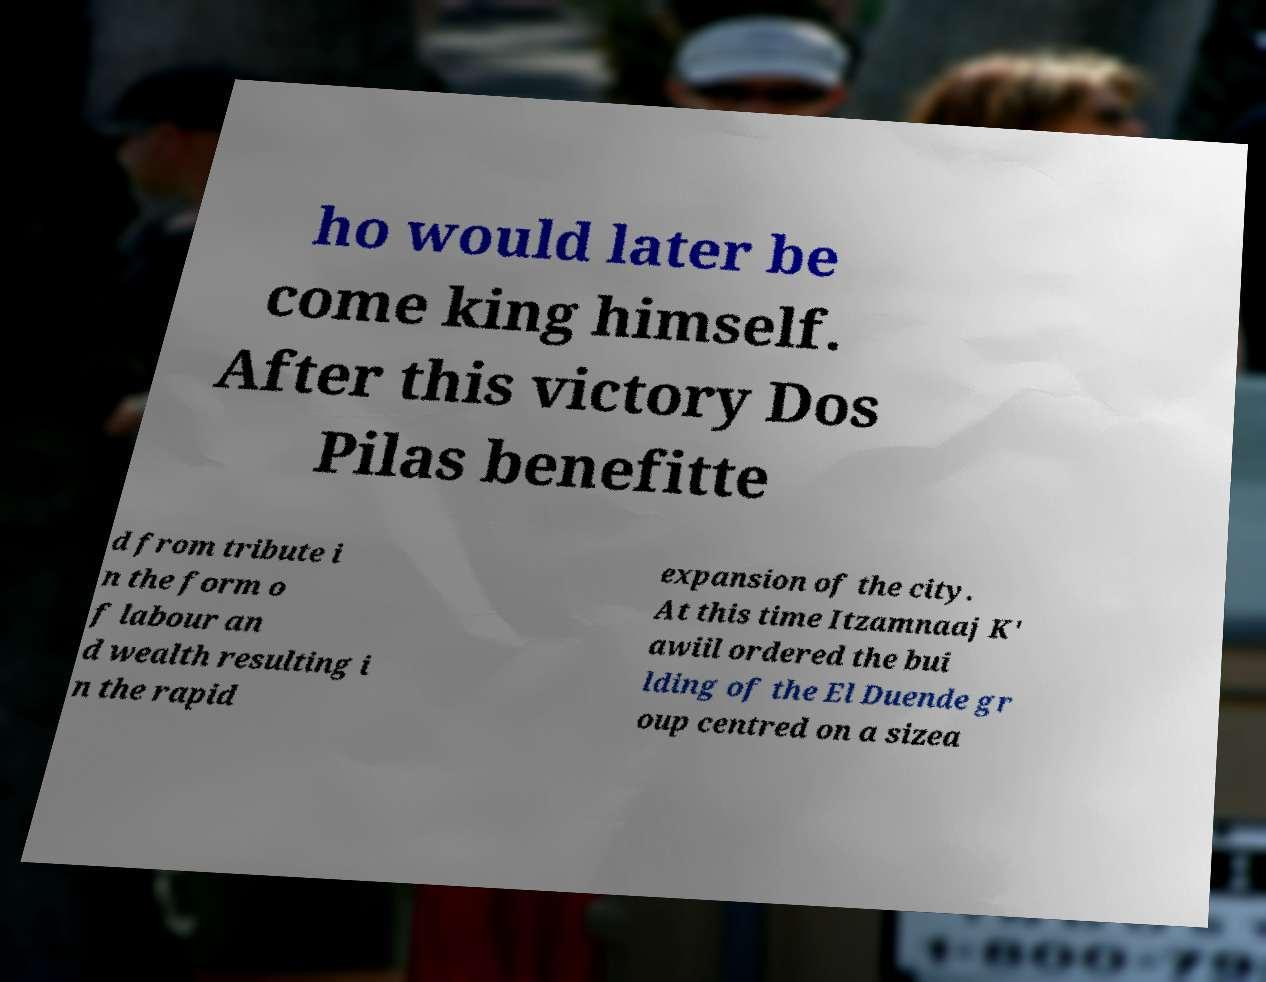I need the written content from this picture converted into text. Can you do that? ho would later be come king himself. After this victory Dos Pilas benefitte d from tribute i n the form o f labour an d wealth resulting i n the rapid expansion of the city. At this time Itzamnaaj K' awiil ordered the bui lding of the El Duende gr oup centred on a sizea 